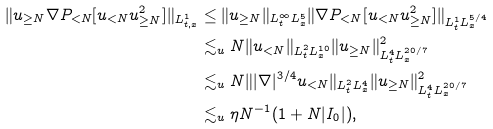<formula> <loc_0><loc_0><loc_500><loc_500>\| u _ { \geq N } \nabla P _ { < N } [ u _ { < N } u _ { \geq N } ^ { 2 } ] \| _ { L _ { t , x } ^ { 1 } } & \leq \| u _ { \geq N } \| _ { L _ { t } ^ { \infty } L _ { x } ^ { 5 } } \| \nabla P _ { < N } [ u _ { < N } u _ { \geq N } ^ { 2 } ] \| _ { L _ { t } ^ { 1 } L _ { x } ^ { 5 / 4 } } \\ & \lesssim _ { u } N \| u _ { < N } \| _ { L _ { t } ^ { 2 } L _ { x } ^ { 1 0 } } \| u _ { \geq N } \| _ { L _ { t } ^ { 4 } L _ { x } ^ { 2 0 / 7 } } ^ { 2 } \\ & \lesssim _ { u } N \| | \nabla | ^ { 3 / 4 } u _ { < N } \| _ { L _ { t } ^ { 2 } L _ { x } ^ { 4 } } \| u _ { \geq N } \| _ { L _ { t } ^ { 4 } L _ { x } ^ { 2 0 / 7 } } ^ { 2 } \\ & \lesssim _ { u } \eta N ^ { - 1 } ( 1 + N | I _ { 0 } | ) ,</formula> 